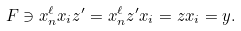Convert formula to latex. <formula><loc_0><loc_0><loc_500><loc_500>F \ni x _ { n } ^ { \ell } x _ { i } z ^ { \prime } = x _ { n } ^ { \ell } z ^ { \prime } x _ { i } = z x _ { i } = y .</formula> 